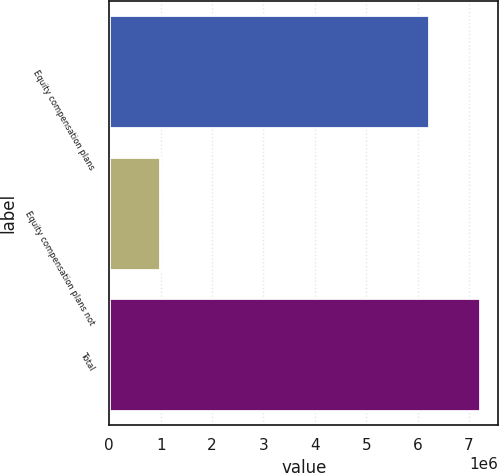<chart> <loc_0><loc_0><loc_500><loc_500><bar_chart><fcel>Equity compensation plans<fcel>Equity compensation plans not<fcel>Total<nl><fcel>6.22622e+06<fcel>979614<fcel>7.20584e+06<nl></chart> 